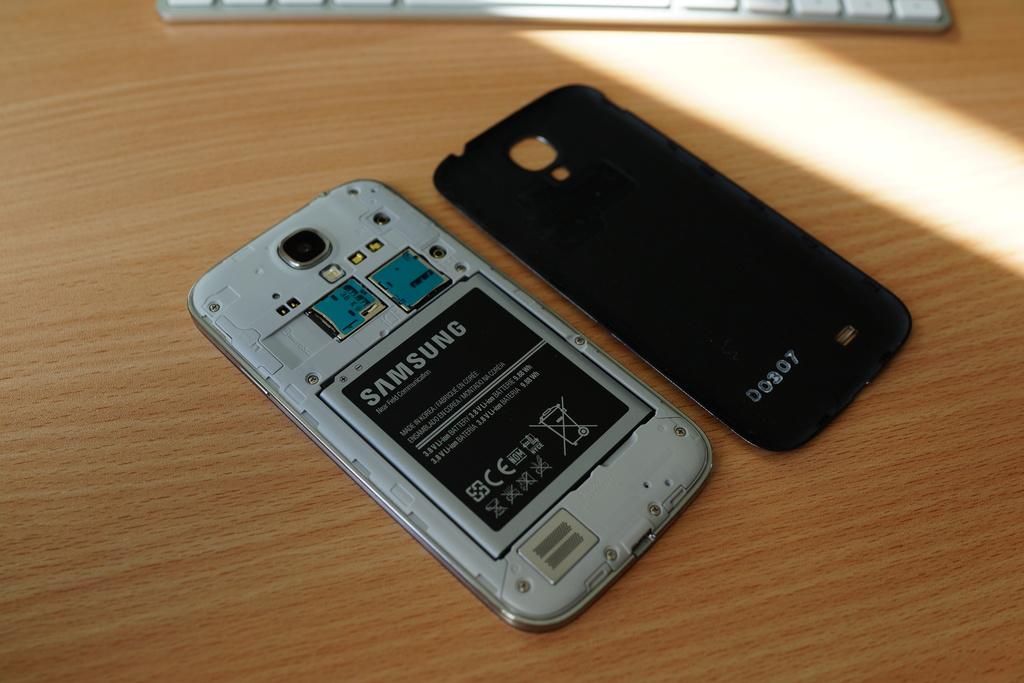What phone brand is this?
Your answer should be compact. Samsung. What brand of cell phone is this?
Offer a terse response. Samsung. 